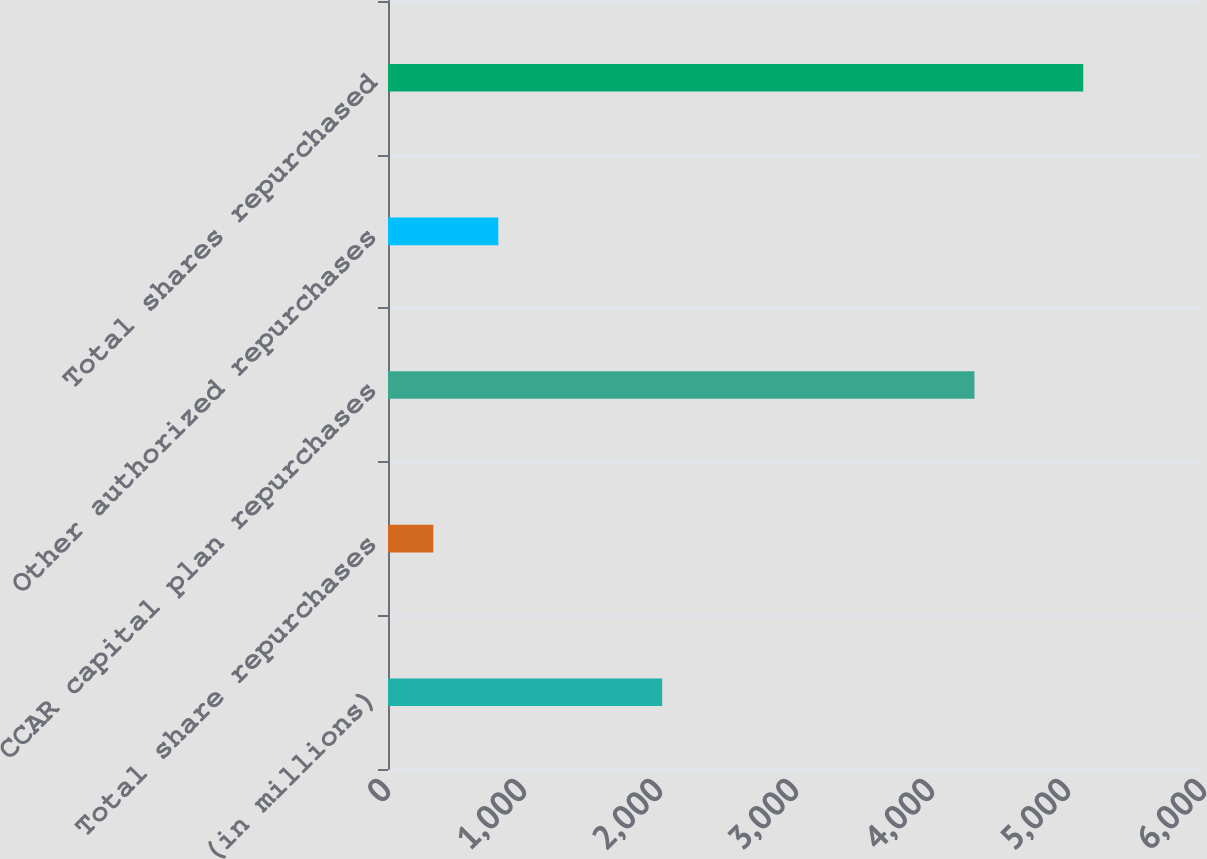Convert chart to OTSL. <chart><loc_0><loc_0><loc_500><loc_500><bar_chart><fcel>(in millions)<fcel>Total share repurchases<fcel>CCAR capital plan repurchases<fcel>Other authorized repurchases<fcel>Total shares repurchased<nl><fcel>2016<fcel>333<fcel>4312<fcel>810.9<fcel>5112<nl></chart> 